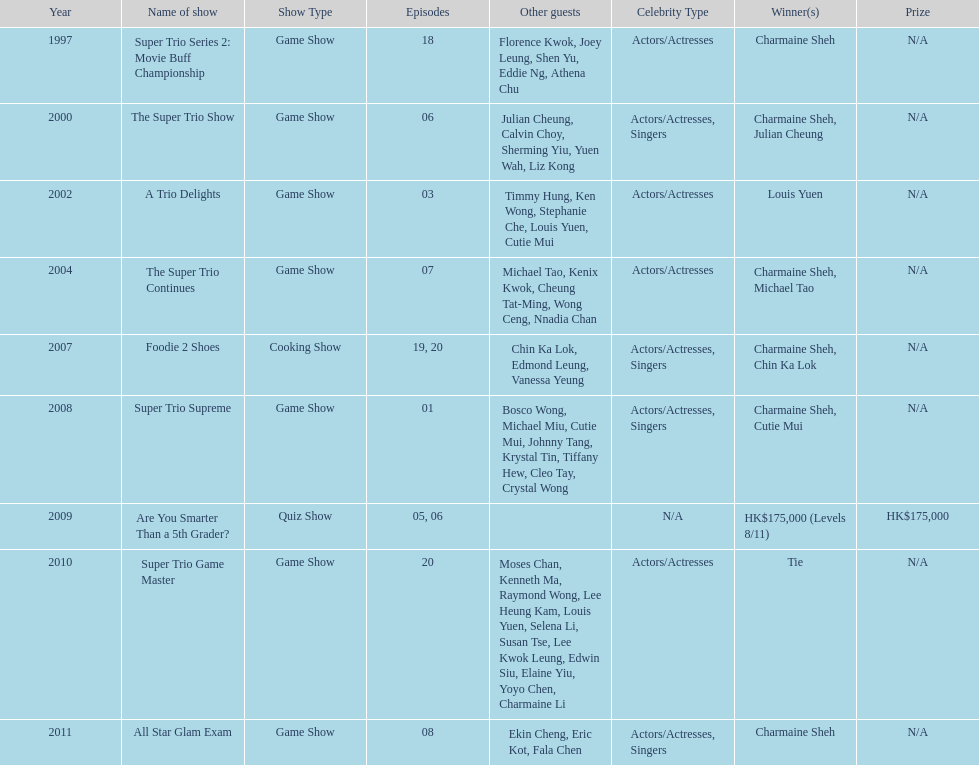What was the total number of trio series shows were charmaine sheh on? 6. 